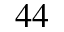<formula> <loc_0><loc_0><loc_500><loc_500>^ { 4 4 }</formula> 